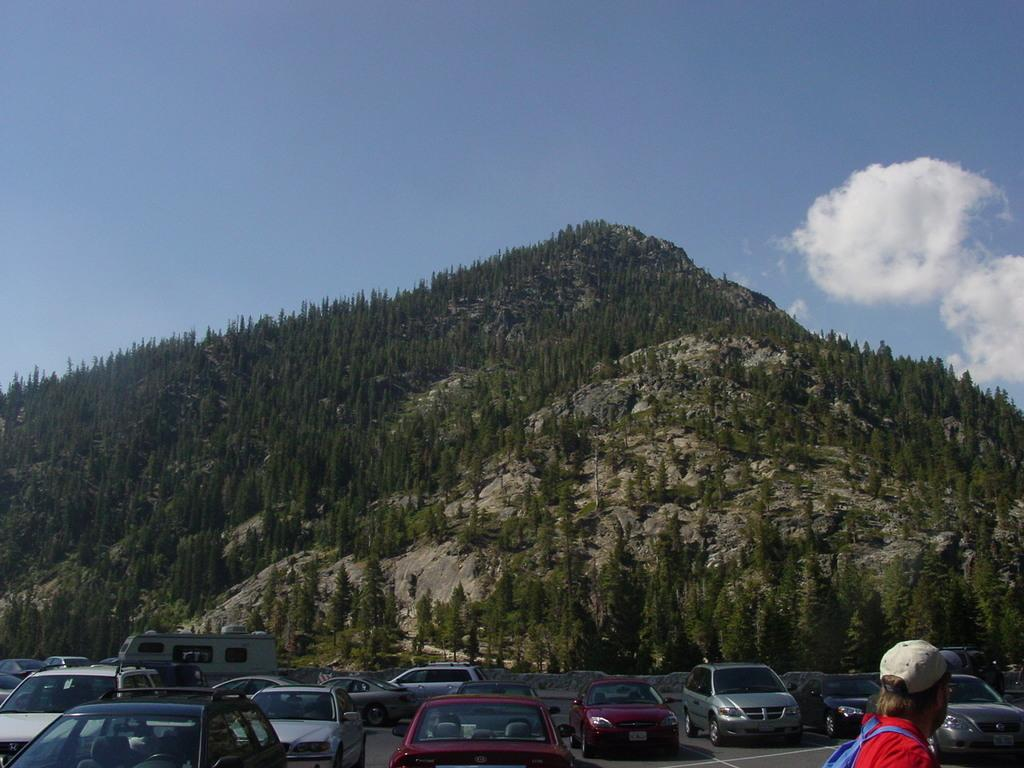What is happening on the road in the image? Vehicles are on the road in the image. Can you describe the man in the image? The man is wearing a bag and cap. What can be seen in the background of the image? There are trees in the background. What is visible in the sky in the image? Clouds are visible in the image. What type of cheese is the man holding in the image? There is no cheese present in the image; the man is wearing a bag and cap. How many dogs are visible in the image? There are no dogs present in the image. 